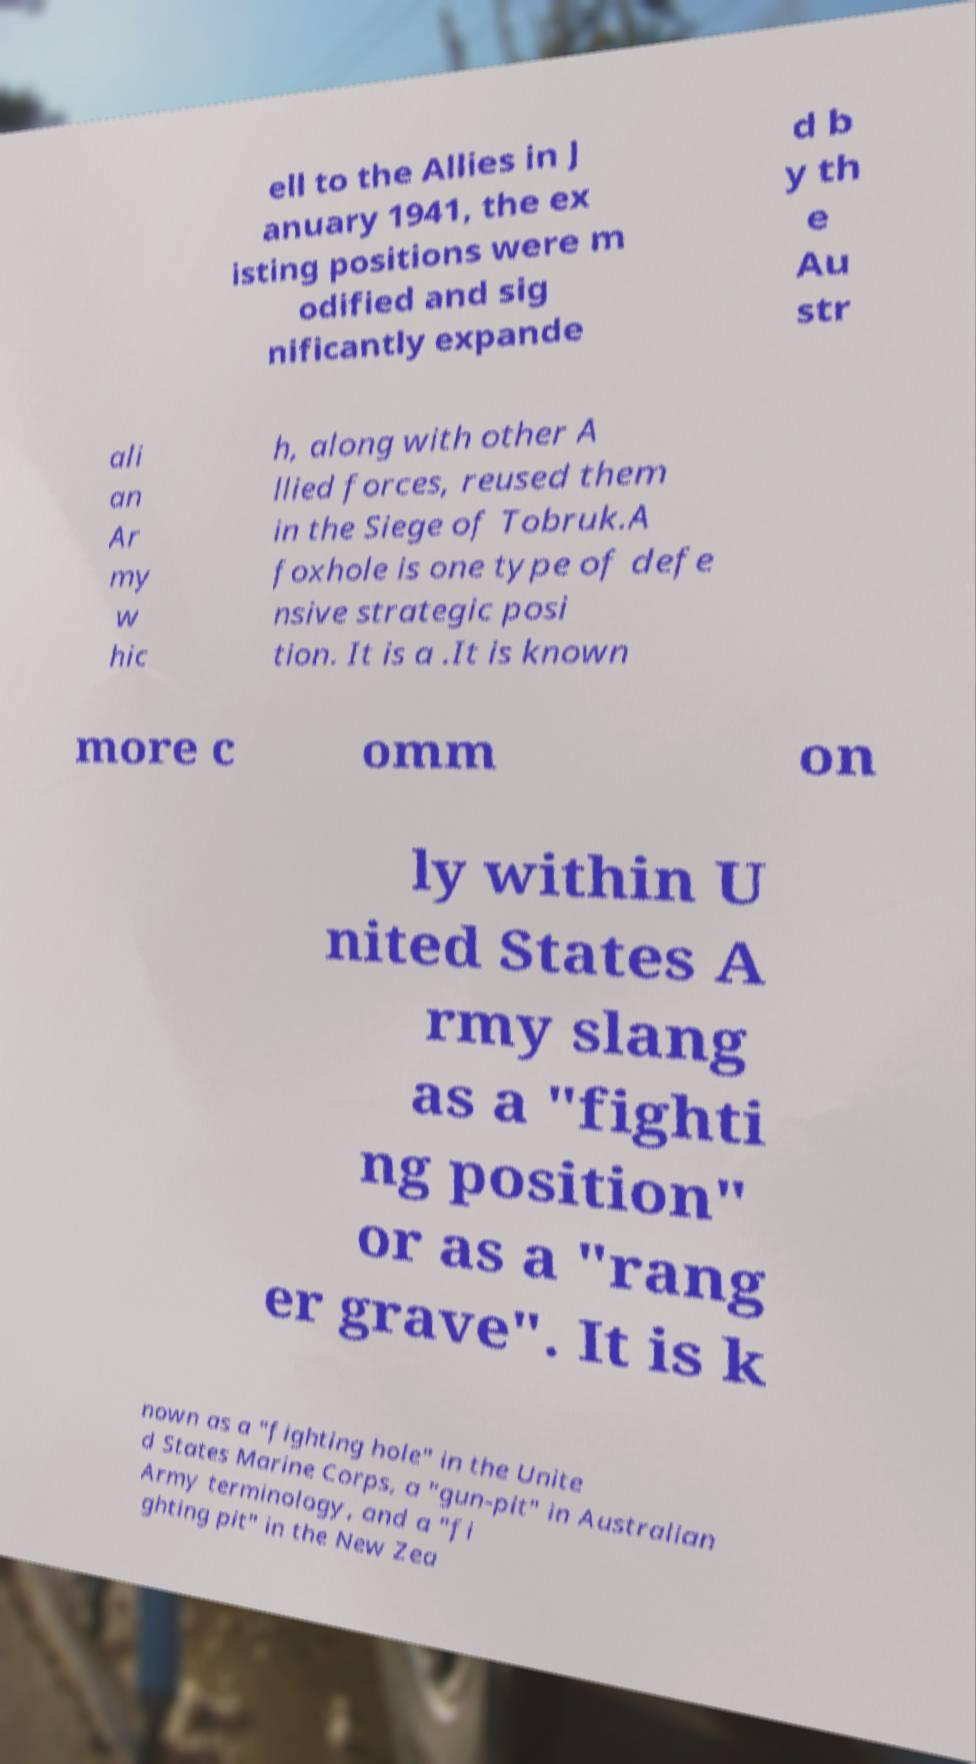For documentation purposes, I need the text within this image transcribed. Could you provide that? ell to the Allies in J anuary 1941, the ex isting positions were m odified and sig nificantly expande d b y th e Au str ali an Ar my w hic h, along with other A llied forces, reused them in the Siege of Tobruk.A foxhole is one type of defe nsive strategic posi tion. It is a .It is known more c omm on ly within U nited States A rmy slang as a "fighti ng position" or as a "rang er grave". It is k nown as a "fighting hole" in the Unite d States Marine Corps, a "gun-pit" in Australian Army terminology, and a "fi ghting pit" in the New Zea 